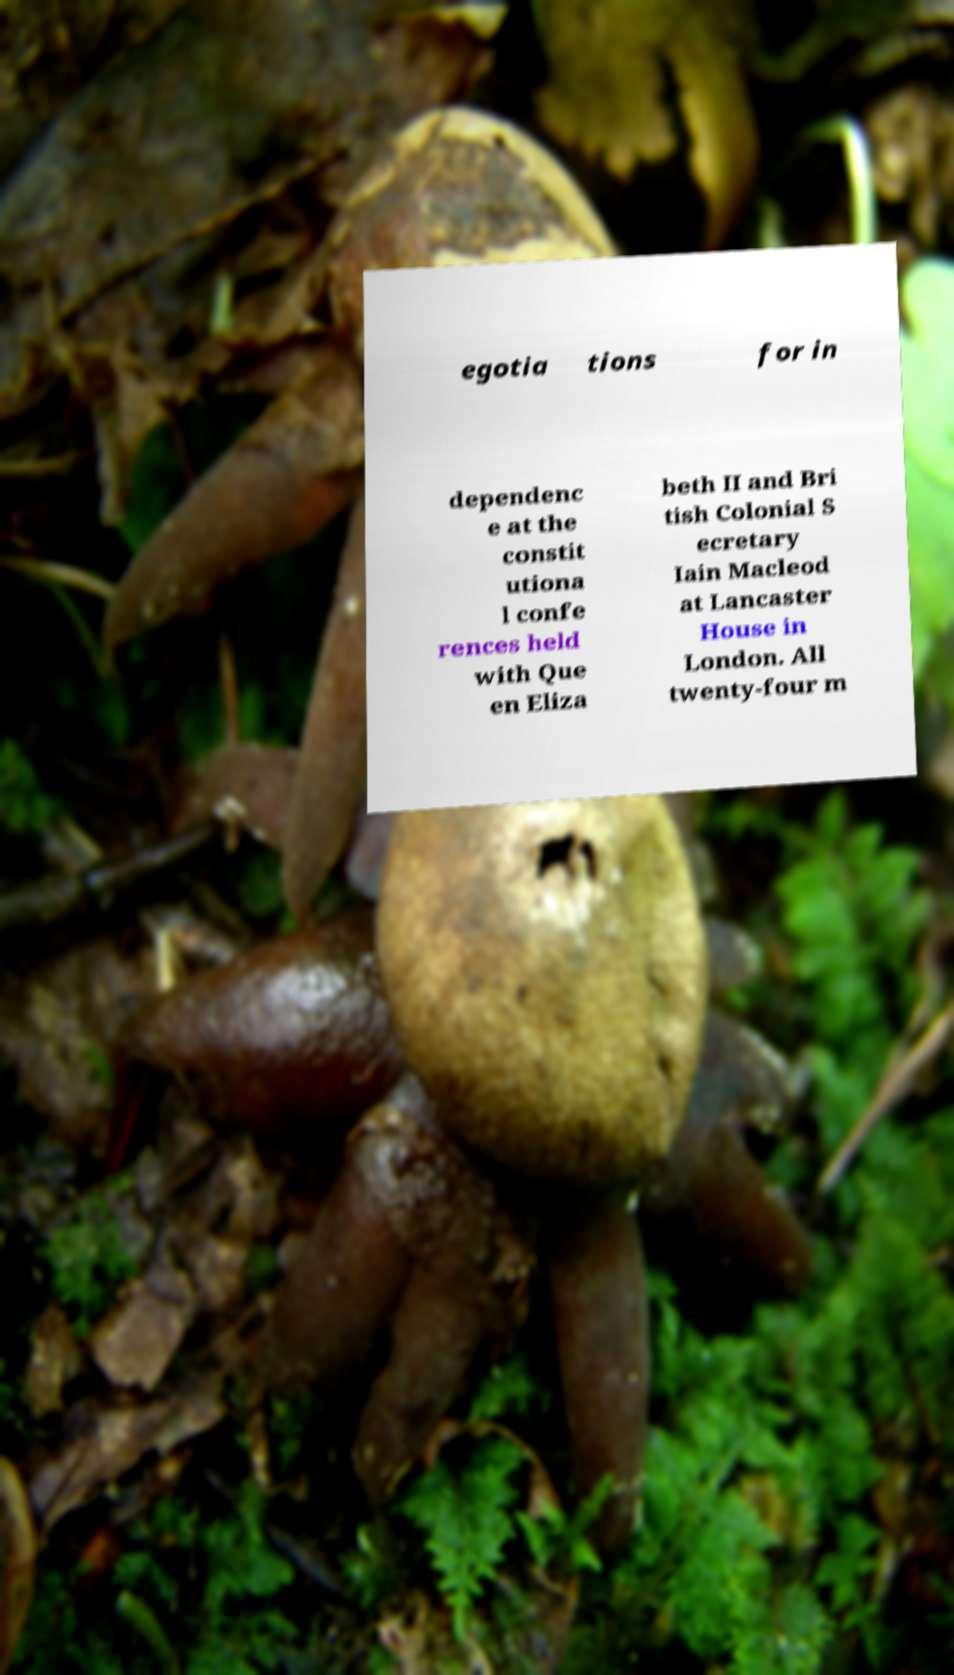For documentation purposes, I need the text within this image transcribed. Could you provide that? egotia tions for in dependenc e at the constit utiona l confe rences held with Que en Eliza beth II and Bri tish Colonial S ecretary Iain Macleod at Lancaster House in London. All twenty-four m 